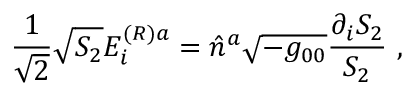Convert formula to latex. <formula><loc_0><loc_0><loc_500><loc_500>{ \frac { 1 } { \sqrt { 2 } } } \sqrt { S _ { 2 } } E _ { i } ^ { ( R ) a } = \hat { n } ^ { a } \sqrt { - g _ { 0 0 } } { \frac { \partial _ { i } S _ { 2 } } { S _ { 2 } } } \ ,</formula> 